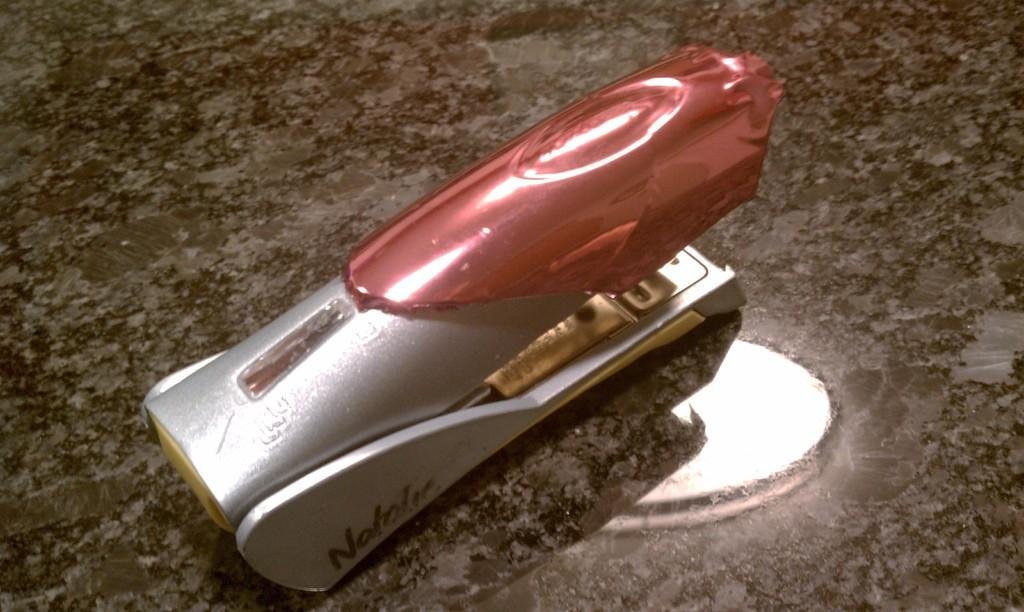What object is in the front of the image? There is a stapler in the front of the image. What type of surface is at the bottom of the image? There is a flat surface at the bottom of the image. What can be seen reflecting on the flat surface? There is a reflection of a light on the flat surface. How many lizards can be seen crawling on the stapler in the image? There are no lizards present in the image; it only features a stapler and a flat surface with a light reflection. 